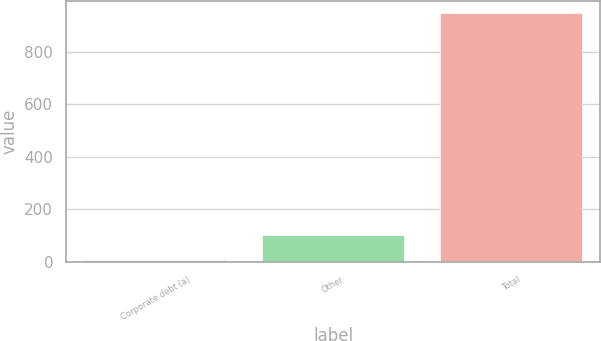Convert chart to OTSL. <chart><loc_0><loc_0><loc_500><loc_500><bar_chart><fcel>Corporate debt (a)<fcel>Other<fcel>Total<nl><fcel>8<fcel>101.8<fcel>946<nl></chart> 